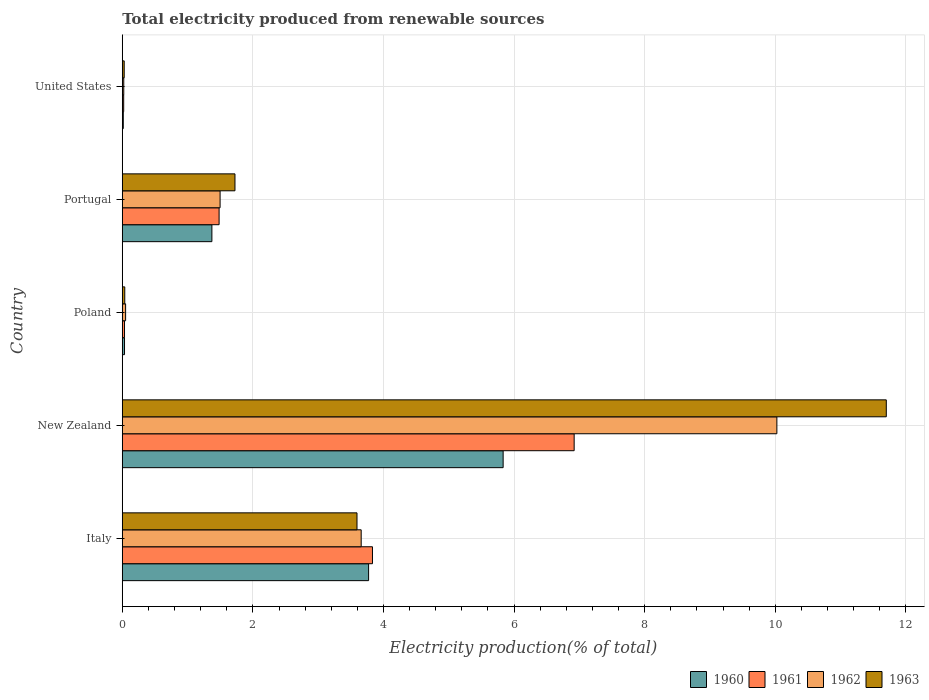How many different coloured bars are there?
Give a very brief answer. 4. How many groups of bars are there?
Keep it short and to the point. 5. What is the label of the 3rd group of bars from the top?
Give a very brief answer. Poland. In how many cases, is the number of bars for a given country not equal to the number of legend labels?
Make the answer very short. 0. What is the total electricity produced in 1961 in Poland?
Your answer should be very brief. 0.03. Across all countries, what is the maximum total electricity produced in 1961?
Your answer should be compact. 6.92. Across all countries, what is the minimum total electricity produced in 1960?
Your answer should be very brief. 0.02. In which country was the total electricity produced in 1962 maximum?
Offer a very short reply. New Zealand. What is the total total electricity produced in 1960 in the graph?
Ensure brevity in your answer.  11.03. What is the difference between the total electricity produced in 1962 in Italy and that in New Zealand?
Your answer should be very brief. -6.37. What is the difference between the total electricity produced in 1963 in Poland and the total electricity produced in 1962 in New Zealand?
Make the answer very short. -9.99. What is the average total electricity produced in 1963 per country?
Provide a succinct answer. 3.42. What is the difference between the total electricity produced in 1961 and total electricity produced in 1962 in United States?
Provide a succinct answer. -0. What is the ratio of the total electricity produced in 1963 in Portugal to that in United States?
Make the answer very short. 58.63. Is the total electricity produced in 1960 in New Zealand less than that in Portugal?
Your answer should be very brief. No. What is the difference between the highest and the second highest total electricity produced in 1962?
Provide a short and direct response. 6.37. What is the difference between the highest and the lowest total electricity produced in 1961?
Your response must be concise. 6.9. In how many countries, is the total electricity produced in 1960 greater than the average total electricity produced in 1960 taken over all countries?
Your response must be concise. 2. Are all the bars in the graph horizontal?
Give a very brief answer. Yes. Are the values on the major ticks of X-axis written in scientific E-notation?
Keep it short and to the point. No. How many legend labels are there?
Keep it short and to the point. 4. What is the title of the graph?
Your answer should be compact. Total electricity produced from renewable sources. What is the Electricity production(% of total) in 1960 in Italy?
Your answer should be compact. 3.77. What is the Electricity production(% of total) in 1961 in Italy?
Make the answer very short. 3.83. What is the Electricity production(% of total) of 1962 in Italy?
Provide a succinct answer. 3.66. What is the Electricity production(% of total) in 1963 in Italy?
Your answer should be compact. 3.59. What is the Electricity production(% of total) in 1960 in New Zealand?
Your answer should be compact. 5.83. What is the Electricity production(% of total) in 1961 in New Zealand?
Offer a very short reply. 6.92. What is the Electricity production(% of total) in 1962 in New Zealand?
Provide a succinct answer. 10.02. What is the Electricity production(% of total) in 1963 in New Zealand?
Your answer should be compact. 11.7. What is the Electricity production(% of total) of 1960 in Poland?
Offer a very short reply. 0.03. What is the Electricity production(% of total) in 1961 in Poland?
Ensure brevity in your answer.  0.03. What is the Electricity production(% of total) in 1962 in Poland?
Offer a terse response. 0.05. What is the Electricity production(% of total) in 1963 in Poland?
Provide a succinct answer. 0.04. What is the Electricity production(% of total) of 1960 in Portugal?
Provide a succinct answer. 1.37. What is the Electricity production(% of total) in 1961 in Portugal?
Provide a succinct answer. 1.48. What is the Electricity production(% of total) of 1962 in Portugal?
Your answer should be compact. 1.5. What is the Electricity production(% of total) of 1963 in Portugal?
Provide a short and direct response. 1.73. What is the Electricity production(% of total) of 1960 in United States?
Ensure brevity in your answer.  0.02. What is the Electricity production(% of total) of 1961 in United States?
Keep it short and to the point. 0.02. What is the Electricity production(% of total) of 1962 in United States?
Offer a terse response. 0.02. What is the Electricity production(% of total) in 1963 in United States?
Ensure brevity in your answer.  0.03. Across all countries, what is the maximum Electricity production(% of total) of 1960?
Offer a terse response. 5.83. Across all countries, what is the maximum Electricity production(% of total) in 1961?
Provide a short and direct response. 6.92. Across all countries, what is the maximum Electricity production(% of total) of 1962?
Keep it short and to the point. 10.02. Across all countries, what is the maximum Electricity production(% of total) in 1963?
Provide a succinct answer. 11.7. Across all countries, what is the minimum Electricity production(% of total) in 1960?
Make the answer very short. 0.02. Across all countries, what is the minimum Electricity production(% of total) of 1961?
Ensure brevity in your answer.  0.02. Across all countries, what is the minimum Electricity production(% of total) of 1962?
Offer a very short reply. 0.02. Across all countries, what is the minimum Electricity production(% of total) in 1963?
Your answer should be very brief. 0.03. What is the total Electricity production(% of total) in 1960 in the graph?
Offer a very short reply. 11.03. What is the total Electricity production(% of total) in 1961 in the graph?
Keep it short and to the point. 12.29. What is the total Electricity production(% of total) of 1962 in the graph?
Make the answer very short. 15.25. What is the total Electricity production(% of total) of 1963 in the graph?
Give a very brief answer. 17.09. What is the difference between the Electricity production(% of total) in 1960 in Italy and that in New Zealand?
Ensure brevity in your answer.  -2.06. What is the difference between the Electricity production(% of total) in 1961 in Italy and that in New Zealand?
Make the answer very short. -3.09. What is the difference between the Electricity production(% of total) in 1962 in Italy and that in New Zealand?
Offer a terse response. -6.37. What is the difference between the Electricity production(% of total) of 1963 in Italy and that in New Zealand?
Ensure brevity in your answer.  -8.11. What is the difference between the Electricity production(% of total) in 1960 in Italy and that in Poland?
Provide a short and direct response. 3.74. What is the difference between the Electricity production(% of total) of 1961 in Italy and that in Poland?
Make the answer very short. 3.8. What is the difference between the Electricity production(% of total) of 1962 in Italy and that in Poland?
Keep it short and to the point. 3.61. What is the difference between the Electricity production(% of total) of 1963 in Italy and that in Poland?
Give a very brief answer. 3.56. What is the difference between the Electricity production(% of total) in 1960 in Italy and that in Portugal?
Your answer should be very brief. 2.4. What is the difference between the Electricity production(% of total) of 1961 in Italy and that in Portugal?
Your response must be concise. 2.35. What is the difference between the Electricity production(% of total) of 1962 in Italy and that in Portugal?
Your response must be concise. 2.16. What is the difference between the Electricity production(% of total) of 1963 in Italy and that in Portugal?
Give a very brief answer. 1.87. What is the difference between the Electricity production(% of total) in 1960 in Italy and that in United States?
Give a very brief answer. 3.76. What is the difference between the Electricity production(% of total) in 1961 in Italy and that in United States?
Provide a succinct answer. 3.81. What is the difference between the Electricity production(% of total) in 1962 in Italy and that in United States?
Your answer should be very brief. 3.64. What is the difference between the Electricity production(% of total) in 1963 in Italy and that in United States?
Offer a very short reply. 3.56. What is the difference between the Electricity production(% of total) in 1960 in New Zealand and that in Poland?
Provide a short and direct response. 5.8. What is the difference between the Electricity production(% of total) in 1961 in New Zealand and that in Poland?
Ensure brevity in your answer.  6.89. What is the difference between the Electricity production(% of total) in 1962 in New Zealand and that in Poland?
Your response must be concise. 9.97. What is the difference between the Electricity production(% of total) in 1963 in New Zealand and that in Poland?
Keep it short and to the point. 11.66. What is the difference between the Electricity production(% of total) in 1960 in New Zealand and that in Portugal?
Provide a short and direct response. 4.46. What is the difference between the Electricity production(% of total) in 1961 in New Zealand and that in Portugal?
Make the answer very short. 5.44. What is the difference between the Electricity production(% of total) in 1962 in New Zealand and that in Portugal?
Give a very brief answer. 8.53. What is the difference between the Electricity production(% of total) in 1963 in New Zealand and that in Portugal?
Give a very brief answer. 9.97. What is the difference between the Electricity production(% of total) of 1960 in New Zealand and that in United States?
Your response must be concise. 5.82. What is the difference between the Electricity production(% of total) of 1961 in New Zealand and that in United States?
Provide a succinct answer. 6.9. What is the difference between the Electricity production(% of total) in 1962 in New Zealand and that in United States?
Your answer should be very brief. 10. What is the difference between the Electricity production(% of total) of 1963 in New Zealand and that in United States?
Ensure brevity in your answer.  11.67. What is the difference between the Electricity production(% of total) of 1960 in Poland and that in Portugal?
Offer a very short reply. -1.34. What is the difference between the Electricity production(% of total) in 1961 in Poland and that in Portugal?
Ensure brevity in your answer.  -1.45. What is the difference between the Electricity production(% of total) of 1962 in Poland and that in Portugal?
Make the answer very short. -1.45. What is the difference between the Electricity production(% of total) in 1963 in Poland and that in Portugal?
Your answer should be very brief. -1.69. What is the difference between the Electricity production(% of total) of 1960 in Poland and that in United States?
Provide a succinct answer. 0.02. What is the difference between the Electricity production(% of total) of 1961 in Poland and that in United States?
Offer a very short reply. 0.01. What is the difference between the Electricity production(% of total) of 1962 in Poland and that in United States?
Provide a short and direct response. 0.03. What is the difference between the Electricity production(% of total) in 1963 in Poland and that in United States?
Make the answer very short. 0.01. What is the difference between the Electricity production(% of total) of 1960 in Portugal and that in United States?
Your answer should be very brief. 1.36. What is the difference between the Electricity production(% of total) in 1961 in Portugal and that in United States?
Make the answer very short. 1.46. What is the difference between the Electricity production(% of total) in 1962 in Portugal and that in United States?
Offer a very short reply. 1.48. What is the difference between the Electricity production(% of total) in 1963 in Portugal and that in United States?
Your answer should be very brief. 1.7. What is the difference between the Electricity production(% of total) in 1960 in Italy and the Electricity production(% of total) in 1961 in New Zealand?
Your answer should be compact. -3.15. What is the difference between the Electricity production(% of total) in 1960 in Italy and the Electricity production(% of total) in 1962 in New Zealand?
Give a very brief answer. -6.25. What is the difference between the Electricity production(% of total) in 1960 in Italy and the Electricity production(% of total) in 1963 in New Zealand?
Offer a terse response. -7.93. What is the difference between the Electricity production(% of total) in 1961 in Italy and the Electricity production(% of total) in 1962 in New Zealand?
Offer a very short reply. -6.19. What is the difference between the Electricity production(% of total) in 1961 in Italy and the Electricity production(% of total) in 1963 in New Zealand?
Your answer should be very brief. -7.87. What is the difference between the Electricity production(% of total) in 1962 in Italy and the Electricity production(% of total) in 1963 in New Zealand?
Provide a succinct answer. -8.04. What is the difference between the Electricity production(% of total) of 1960 in Italy and the Electricity production(% of total) of 1961 in Poland?
Your response must be concise. 3.74. What is the difference between the Electricity production(% of total) of 1960 in Italy and the Electricity production(% of total) of 1962 in Poland?
Give a very brief answer. 3.72. What is the difference between the Electricity production(% of total) in 1960 in Italy and the Electricity production(% of total) in 1963 in Poland?
Give a very brief answer. 3.73. What is the difference between the Electricity production(% of total) in 1961 in Italy and the Electricity production(% of total) in 1962 in Poland?
Ensure brevity in your answer.  3.78. What is the difference between the Electricity production(% of total) in 1961 in Italy and the Electricity production(% of total) in 1963 in Poland?
Your response must be concise. 3.79. What is the difference between the Electricity production(% of total) of 1962 in Italy and the Electricity production(% of total) of 1963 in Poland?
Ensure brevity in your answer.  3.62. What is the difference between the Electricity production(% of total) in 1960 in Italy and the Electricity production(% of total) in 1961 in Portugal?
Your answer should be very brief. 2.29. What is the difference between the Electricity production(% of total) of 1960 in Italy and the Electricity production(% of total) of 1962 in Portugal?
Provide a short and direct response. 2.27. What is the difference between the Electricity production(% of total) of 1960 in Italy and the Electricity production(% of total) of 1963 in Portugal?
Your response must be concise. 2.05. What is the difference between the Electricity production(% of total) in 1961 in Italy and the Electricity production(% of total) in 1962 in Portugal?
Provide a succinct answer. 2.33. What is the difference between the Electricity production(% of total) in 1961 in Italy and the Electricity production(% of total) in 1963 in Portugal?
Provide a succinct answer. 2.11. What is the difference between the Electricity production(% of total) in 1962 in Italy and the Electricity production(% of total) in 1963 in Portugal?
Your answer should be compact. 1.93. What is the difference between the Electricity production(% of total) in 1960 in Italy and the Electricity production(% of total) in 1961 in United States?
Make the answer very short. 3.75. What is the difference between the Electricity production(% of total) in 1960 in Italy and the Electricity production(% of total) in 1962 in United States?
Your response must be concise. 3.75. What is the difference between the Electricity production(% of total) of 1960 in Italy and the Electricity production(% of total) of 1963 in United States?
Offer a very short reply. 3.74. What is the difference between the Electricity production(% of total) in 1961 in Italy and the Electricity production(% of total) in 1962 in United States?
Provide a short and direct response. 3.81. What is the difference between the Electricity production(% of total) in 1961 in Italy and the Electricity production(% of total) in 1963 in United States?
Make the answer very short. 3.8. What is the difference between the Electricity production(% of total) of 1962 in Italy and the Electricity production(% of total) of 1963 in United States?
Provide a succinct answer. 3.63. What is the difference between the Electricity production(% of total) in 1960 in New Zealand and the Electricity production(% of total) in 1961 in Poland?
Provide a succinct answer. 5.8. What is the difference between the Electricity production(% of total) in 1960 in New Zealand and the Electricity production(% of total) in 1962 in Poland?
Your response must be concise. 5.78. What is the difference between the Electricity production(% of total) in 1960 in New Zealand and the Electricity production(% of total) in 1963 in Poland?
Your response must be concise. 5.79. What is the difference between the Electricity production(% of total) in 1961 in New Zealand and the Electricity production(% of total) in 1962 in Poland?
Your answer should be very brief. 6.87. What is the difference between the Electricity production(% of total) in 1961 in New Zealand and the Electricity production(% of total) in 1963 in Poland?
Keep it short and to the point. 6.88. What is the difference between the Electricity production(% of total) in 1962 in New Zealand and the Electricity production(% of total) in 1963 in Poland?
Offer a terse response. 9.99. What is the difference between the Electricity production(% of total) of 1960 in New Zealand and the Electricity production(% of total) of 1961 in Portugal?
Give a very brief answer. 4.35. What is the difference between the Electricity production(% of total) of 1960 in New Zealand and the Electricity production(% of total) of 1962 in Portugal?
Your answer should be compact. 4.33. What is the difference between the Electricity production(% of total) in 1960 in New Zealand and the Electricity production(% of total) in 1963 in Portugal?
Your answer should be very brief. 4.11. What is the difference between the Electricity production(% of total) in 1961 in New Zealand and the Electricity production(% of total) in 1962 in Portugal?
Provide a short and direct response. 5.42. What is the difference between the Electricity production(% of total) of 1961 in New Zealand and the Electricity production(% of total) of 1963 in Portugal?
Make the answer very short. 5.19. What is the difference between the Electricity production(% of total) of 1962 in New Zealand and the Electricity production(% of total) of 1963 in Portugal?
Offer a very short reply. 8.3. What is the difference between the Electricity production(% of total) in 1960 in New Zealand and the Electricity production(% of total) in 1961 in United States?
Make the answer very short. 5.81. What is the difference between the Electricity production(% of total) in 1960 in New Zealand and the Electricity production(% of total) in 1962 in United States?
Your response must be concise. 5.81. What is the difference between the Electricity production(% of total) in 1960 in New Zealand and the Electricity production(% of total) in 1963 in United States?
Provide a succinct answer. 5.8. What is the difference between the Electricity production(% of total) of 1961 in New Zealand and the Electricity production(% of total) of 1962 in United States?
Your answer should be very brief. 6.9. What is the difference between the Electricity production(% of total) in 1961 in New Zealand and the Electricity production(% of total) in 1963 in United States?
Your answer should be very brief. 6.89. What is the difference between the Electricity production(% of total) of 1962 in New Zealand and the Electricity production(% of total) of 1963 in United States?
Ensure brevity in your answer.  10. What is the difference between the Electricity production(% of total) in 1960 in Poland and the Electricity production(% of total) in 1961 in Portugal?
Provide a succinct answer. -1.45. What is the difference between the Electricity production(% of total) of 1960 in Poland and the Electricity production(% of total) of 1962 in Portugal?
Keep it short and to the point. -1.46. What is the difference between the Electricity production(% of total) in 1960 in Poland and the Electricity production(% of total) in 1963 in Portugal?
Your answer should be very brief. -1.69. What is the difference between the Electricity production(% of total) in 1961 in Poland and the Electricity production(% of total) in 1962 in Portugal?
Offer a terse response. -1.46. What is the difference between the Electricity production(% of total) of 1961 in Poland and the Electricity production(% of total) of 1963 in Portugal?
Provide a succinct answer. -1.69. What is the difference between the Electricity production(% of total) of 1962 in Poland and the Electricity production(% of total) of 1963 in Portugal?
Offer a very short reply. -1.67. What is the difference between the Electricity production(% of total) of 1960 in Poland and the Electricity production(% of total) of 1961 in United States?
Your answer should be very brief. 0.01. What is the difference between the Electricity production(% of total) in 1960 in Poland and the Electricity production(% of total) in 1962 in United States?
Ensure brevity in your answer.  0.01. What is the difference between the Electricity production(% of total) of 1960 in Poland and the Electricity production(% of total) of 1963 in United States?
Keep it short and to the point. 0. What is the difference between the Electricity production(% of total) of 1961 in Poland and the Electricity production(% of total) of 1962 in United States?
Make the answer very short. 0.01. What is the difference between the Electricity production(% of total) of 1961 in Poland and the Electricity production(% of total) of 1963 in United States?
Provide a succinct answer. 0. What is the difference between the Electricity production(% of total) in 1962 in Poland and the Electricity production(% of total) in 1963 in United States?
Your answer should be compact. 0.02. What is the difference between the Electricity production(% of total) in 1960 in Portugal and the Electricity production(% of total) in 1961 in United States?
Offer a terse response. 1.35. What is the difference between the Electricity production(% of total) in 1960 in Portugal and the Electricity production(% of total) in 1962 in United States?
Ensure brevity in your answer.  1.35. What is the difference between the Electricity production(% of total) of 1960 in Portugal and the Electricity production(% of total) of 1963 in United States?
Your answer should be very brief. 1.34. What is the difference between the Electricity production(% of total) in 1961 in Portugal and the Electricity production(% of total) in 1962 in United States?
Give a very brief answer. 1.46. What is the difference between the Electricity production(% of total) of 1961 in Portugal and the Electricity production(% of total) of 1963 in United States?
Ensure brevity in your answer.  1.45. What is the difference between the Electricity production(% of total) of 1962 in Portugal and the Electricity production(% of total) of 1963 in United States?
Keep it short and to the point. 1.47. What is the average Electricity production(% of total) of 1960 per country?
Your response must be concise. 2.21. What is the average Electricity production(% of total) of 1961 per country?
Ensure brevity in your answer.  2.46. What is the average Electricity production(% of total) in 1962 per country?
Provide a succinct answer. 3.05. What is the average Electricity production(% of total) in 1963 per country?
Offer a terse response. 3.42. What is the difference between the Electricity production(% of total) of 1960 and Electricity production(% of total) of 1961 in Italy?
Your answer should be compact. -0.06. What is the difference between the Electricity production(% of total) of 1960 and Electricity production(% of total) of 1962 in Italy?
Offer a very short reply. 0.11. What is the difference between the Electricity production(% of total) in 1960 and Electricity production(% of total) in 1963 in Italy?
Offer a terse response. 0.18. What is the difference between the Electricity production(% of total) in 1961 and Electricity production(% of total) in 1962 in Italy?
Give a very brief answer. 0.17. What is the difference between the Electricity production(% of total) of 1961 and Electricity production(% of total) of 1963 in Italy?
Give a very brief answer. 0.24. What is the difference between the Electricity production(% of total) of 1962 and Electricity production(% of total) of 1963 in Italy?
Make the answer very short. 0.06. What is the difference between the Electricity production(% of total) of 1960 and Electricity production(% of total) of 1961 in New Zealand?
Offer a terse response. -1.09. What is the difference between the Electricity production(% of total) in 1960 and Electricity production(% of total) in 1962 in New Zealand?
Offer a very short reply. -4.19. What is the difference between the Electricity production(% of total) in 1960 and Electricity production(% of total) in 1963 in New Zealand?
Your response must be concise. -5.87. What is the difference between the Electricity production(% of total) in 1961 and Electricity production(% of total) in 1962 in New Zealand?
Provide a short and direct response. -3.1. What is the difference between the Electricity production(% of total) in 1961 and Electricity production(% of total) in 1963 in New Zealand?
Keep it short and to the point. -4.78. What is the difference between the Electricity production(% of total) in 1962 and Electricity production(% of total) in 1963 in New Zealand?
Your answer should be compact. -1.68. What is the difference between the Electricity production(% of total) of 1960 and Electricity production(% of total) of 1962 in Poland?
Give a very brief answer. -0.02. What is the difference between the Electricity production(% of total) in 1960 and Electricity production(% of total) in 1963 in Poland?
Provide a succinct answer. -0. What is the difference between the Electricity production(% of total) of 1961 and Electricity production(% of total) of 1962 in Poland?
Provide a succinct answer. -0.02. What is the difference between the Electricity production(% of total) in 1961 and Electricity production(% of total) in 1963 in Poland?
Ensure brevity in your answer.  -0. What is the difference between the Electricity production(% of total) of 1962 and Electricity production(% of total) of 1963 in Poland?
Provide a short and direct response. 0.01. What is the difference between the Electricity production(% of total) in 1960 and Electricity production(% of total) in 1961 in Portugal?
Your answer should be compact. -0.11. What is the difference between the Electricity production(% of total) in 1960 and Electricity production(% of total) in 1962 in Portugal?
Your answer should be compact. -0.13. What is the difference between the Electricity production(% of total) of 1960 and Electricity production(% of total) of 1963 in Portugal?
Offer a very short reply. -0.35. What is the difference between the Electricity production(% of total) in 1961 and Electricity production(% of total) in 1962 in Portugal?
Provide a short and direct response. -0.02. What is the difference between the Electricity production(% of total) of 1961 and Electricity production(% of total) of 1963 in Portugal?
Your answer should be very brief. -0.24. What is the difference between the Electricity production(% of total) in 1962 and Electricity production(% of total) in 1963 in Portugal?
Keep it short and to the point. -0.23. What is the difference between the Electricity production(% of total) of 1960 and Electricity production(% of total) of 1961 in United States?
Your answer should be very brief. -0.01. What is the difference between the Electricity production(% of total) in 1960 and Electricity production(% of total) in 1962 in United States?
Make the answer very short. -0.01. What is the difference between the Electricity production(% of total) of 1960 and Electricity production(% of total) of 1963 in United States?
Provide a short and direct response. -0.01. What is the difference between the Electricity production(% of total) of 1961 and Electricity production(% of total) of 1962 in United States?
Give a very brief answer. -0. What is the difference between the Electricity production(% of total) of 1961 and Electricity production(% of total) of 1963 in United States?
Keep it short and to the point. -0.01. What is the difference between the Electricity production(% of total) in 1962 and Electricity production(% of total) in 1963 in United States?
Keep it short and to the point. -0.01. What is the ratio of the Electricity production(% of total) in 1960 in Italy to that in New Zealand?
Offer a very short reply. 0.65. What is the ratio of the Electricity production(% of total) in 1961 in Italy to that in New Zealand?
Ensure brevity in your answer.  0.55. What is the ratio of the Electricity production(% of total) in 1962 in Italy to that in New Zealand?
Make the answer very short. 0.36. What is the ratio of the Electricity production(% of total) of 1963 in Italy to that in New Zealand?
Offer a terse response. 0.31. What is the ratio of the Electricity production(% of total) of 1960 in Italy to that in Poland?
Your answer should be compact. 110.45. What is the ratio of the Electricity production(% of total) in 1961 in Italy to that in Poland?
Provide a succinct answer. 112.3. What is the ratio of the Electricity production(% of total) of 1962 in Italy to that in Poland?
Give a very brief answer. 71.88. What is the ratio of the Electricity production(% of total) in 1963 in Italy to that in Poland?
Provide a short and direct response. 94.84. What is the ratio of the Electricity production(% of total) in 1960 in Italy to that in Portugal?
Give a very brief answer. 2.75. What is the ratio of the Electricity production(% of total) of 1961 in Italy to that in Portugal?
Provide a succinct answer. 2.58. What is the ratio of the Electricity production(% of total) in 1962 in Italy to that in Portugal?
Provide a short and direct response. 2.44. What is the ratio of the Electricity production(% of total) of 1963 in Italy to that in Portugal?
Your response must be concise. 2.08. What is the ratio of the Electricity production(% of total) in 1960 in Italy to that in United States?
Your answer should be very brief. 247.25. What is the ratio of the Electricity production(% of total) of 1961 in Italy to that in United States?
Keep it short and to the point. 177.87. What is the ratio of the Electricity production(% of total) of 1962 in Italy to that in United States?
Offer a terse response. 160.56. What is the ratio of the Electricity production(% of total) of 1963 in Italy to that in United States?
Your response must be concise. 122.12. What is the ratio of the Electricity production(% of total) of 1960 in New Zealand to that in Poland?
Keep it short and to the point. 170.79. What is the ratio of the Electricity production(% of total) in 1961 in New Zealand to that in Poland?
Offer a very short reply. 202.83. What is the ratio of the Electricity production(% of total) of 1962 in New Zealand to that in Poland?
Make the answer very short. 196.95. What is the ratio of the Electricity production(% of total) of 1963 in New Zealand to that in Poland?
Your answer should be very brief. 308.73. What is the ratio of the Electricity production(% of total) of 1960 in New Zealand to that in Portugal?
Your response must be concise. 4.25. What is the ratio of the Electricity production(% of total) of 1961 in New Zealand to that in Portugal?
Offer a terse response. 4.67. What is the ratio of the Electricity production(% of total) of 1962 in New Zealand to that in Portugal?
Keep it short and to the point. 6.69. What is the ratio of the Electricity production(% of total) in 1963 in New Zealand to that in Portugal?
Ensure brevity in your answer.  6.78. What is the ratio of the Electricity production(% of total) in 1960 in New Zealand to that in United States?
Your response must be concise. 382.31. What is the ratio of the Electricity production(% of total) of 1961 in New Zealand to that in United States?
Your answer should be compact. 321.25. What is the ratio of the Electricity production(% of total) in 1962 in New Zealand to that in United States?
Provide a succinct answer. 439.93. What is the ratio of the Electricity production(% of total) of 1963 in New Zealand to that in United States?
Ensure brevity in your answer.  397.5. What is the ratio of the Electricity production(% of total) of 1960 in Poland to that in Portugal?
Offer a very short reply. 0.02. What is the ratio of the Electricity production(% of total) in 1961 in Poland to that in Portugal?
Ensure brevity in your answer.  0.02. What is the ratio of the Electricity production(% of total) of 1962 in Poland to that in Portugal?
Offer a terse response. 0.03. What is the ratio of the Electricity production(% of total) in 1963 in Poland to that in Portugal?
Keep it short and to the point. 0.02. What is the ratio of the Electricity production(% of total) in 1960 in Poland to that in United States?
Make the answer very short. 2.24. What is the ratio of the Electricity production(% of total) in 1961 in Poland to that in United States?
Provide a short and direct response. 1.58. What is the ratio of the Electricity production(% of total) in 1962 in Poland to that in United States?
Provide a succinct answer. 2.23. What is the ratio of the Electricity production(% of total) in 1963 in Poland to that in United States?
Offer a terse response. 1.29. What is the ratio of the Electricity production(% of total) of 1960 in Portugal to that in United States?
Ensure brevity in your answer.  89.96. What is the ratio of the Electricity production(% of total) in 1961 in Portugal to that in United States?
Provide a short and direct response. 68.83. What is the ratio of the Electricity production(% of total) of 1962 in Portugal to that in United States?
Provide a short and direct response. 65.74. What is the ratio of the Electricity production(% of total) of 1963 in Portugal to that in United States?
Give a very brief answer. 58.63. What is the difference between the highest and the second highest Electricity production(% of total) in 1960?
Offer a terse response. 2.06. What is the difference between the highest and the second highest Electricity production(% of total) of 1961?
Ensure brevity in your answer.  3.09. What is the difference between the highest and the second highest Electricity production(% of total) of 1962?
Your answer should be compact. 6.37. What is the difference between the highest and the second highest Electricity production(% of total) of 1963?
Provide a succinct answer. 8.11. What is the difference between the highest and the lowest Electricity production(% of total) in 1960?
Ensure brevity in your answer.  5.82. What is the difference between the highest and the lowest Electricity production(% of total) of 1961?
Ensure brevity in your answer.  6.9. What is the difference between the highest and the lowest Electricity production(% of total) in 1962?
Your answer should be compact. 10. What is the difference between the highest and the lowest Electricity production(% of total) in 1963?
Ensure brevity in your answer.  11.67. 